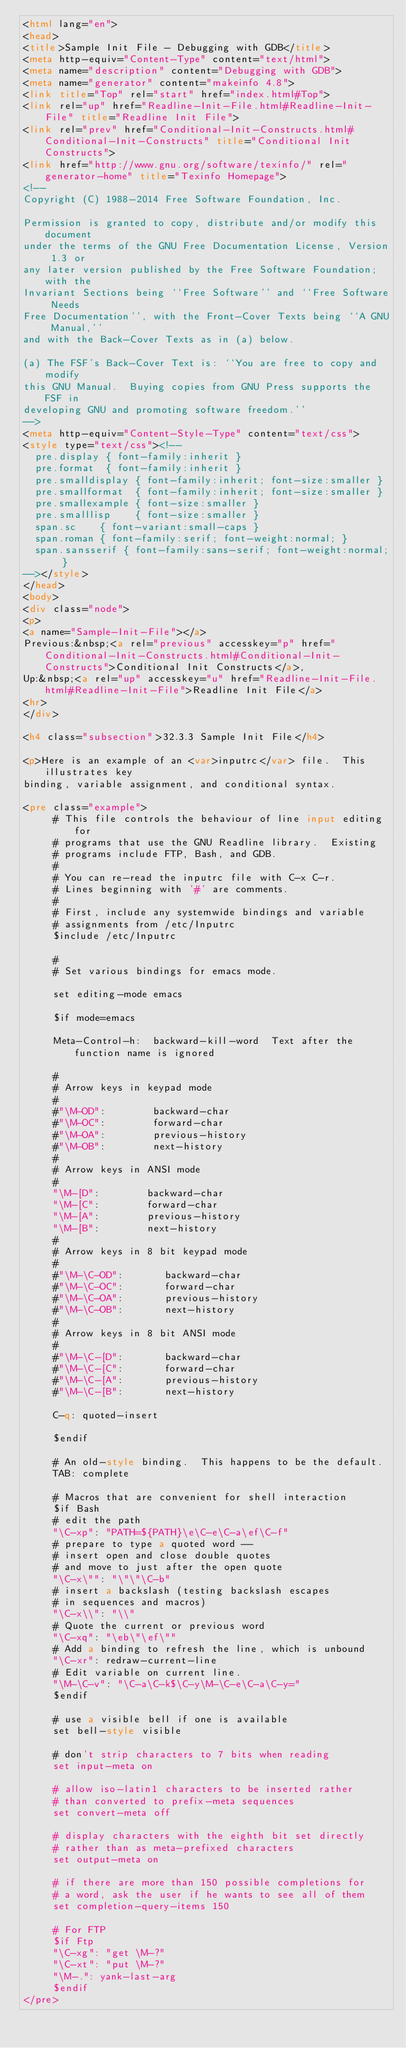<code> <loc_0><loc_0><loc_500><loc_500><_HTML_><html lang="en">
<head>
<title>Sample Init File - Debugging with GDB</title>
<meta http-equiv="Content-Type" content="text/html">
<meta name="description" content="Debugging with GDB">
<meta name="generator" content="makeinfo 4.8">
<link title="Top" rel="start" href="index.html#Top">
<link rel="up" href="Readline-Init-File.html#Readline-Init-File" title="Readline Init File">
<link rel="prev" href="Conditional-Init-Constructs.html#Conditional-Init-Constructs" title="Conditional Init Constructs">
<link href="http://www.gnu.org/software/texinfo/" rel="generator-home" title="Texinfo Homepage">
<!--
Copyright (C) 1988-2014 Free Software Foundation, Inc.

Permission is granted to copy, distribute and/or modify this document
under the terms of the GNU Free Documentation License, Version 1.3 or
any later version published by the Free Software Foundation; with the
Invariant Sections being ``Free Software'' and ``Free Software Needs
Free Documentation'', with the Front-Cover Texts being ``A GNU Manual,''
and with the Back-Cover Texts as in (a) below.

(a) The FSF's Back-Cover Text is: ``You are free to copy and modify
this GNU Manual.  Buying copies from GNU Press supports the FSF in
developing GNU and promoting software freedom.''
-->
<meta http-equiv="Content-Style-Type" content="text/css">
<style type="text/css"><!--
  pre.display { font-family:inherit }
  pre.format  { font-family:inherit }
  pre.smalldisplay { font-family:inherit; font-size:smaller }
  pre.smallformat  { font-family:inherit; font-size:smaller }
  pre.smallexample { font-size:smaller }
  pre.smalllisp    { font-size:smaller }
  span.sc    { font-variant:small-caps }
  span.roman { font-family:serif; font-weight:normal; } 
  span.sansserif { font-family:sans-serif; font-weight:normal; } 
--></style>
</head>
<body>
<div class="node">
<p>
<a name="Sample-Init-File"></a>
Previous:&nbsp;<a rel="previous" accesskey="p" href="Conditional-Init-Constructs.html#Conditional-Init-Constructs">Conditional Init Constructs</a>,
Up:&nbsp;<a rel="up" accesskey="u" href="Readline-Init-File.html#Readline-Init-File">Readline Init File</a>
<hr>
</div>

<h4 class="subsection">32.3.3 Sample Init File</h4>

<p>Here is an example of an <var>inputrc</var> file.  This illustrates key
binding, variable assignment, and conditional syntax.

<pre class="example">     
     # This file controls the behaviour of line input editing for
     # programs that use the GNU Readline library.  Existing
     # programs include FTP, Bash, and GDB.
     #
     # You can re-read the inputrc file with C-x C-r.
     # Lines beginning with '#' are comments.
     #
     # First, include any systemwide bindings and variable
     # assignments from /etc/Inputrc
     $include /etc/Inputrc
     
     #
     # Set various bindings for emacs mode.
     
     set editing-mode emacs
     
     $if mode=emacs
     
     Meta-Control-h:	backward-kill-word	Text after the function name is ignored
     
     #
     # Arrow keys in keypad mode
     #
     #"\M-OD":        backward-char
     #"\M-OC":        forward-char
     #"\M-OA":        previous-history
     #"\M-OB":        next-history
     #
     # Arrow keys in ANSI mode
     #
     "\M-[D":        backward-char
     "\M-[C":        forward-char
     "\M-[A":        previous-history
     "\M-[B":        next-history
     #
     # Arrow keys in 8 bit keypad mode
     #
     #"\M-\C-OD":       backward-char
     #"\M-\C-OC":       forward-char
     #"\M-\C-OA":       previous-history
     #"\M-\C-OB":       next-history
     #
     # Arrow keys in 8 bit ANSI mode
     #
     #"\M-\C-[D":       backward-char
     #"\M-\C-[C":       forward-char
     #"\M-\C-[A":       previous-history
     #"\M-\C-[B":       next-history
     
     C-q: quoted-insert
     
     $endif
     
     # An old-style binding.  This happens to be the default.
     TAB: complete
     
     # Macros that are convenient for shell interaction
     $if Bash
     # edit the path
     "\C-xp": "PATH=${PATH}\e\C-e\C-a\ef\C-f"
     # prepare to type a quoted word --
     # insert open and close double quotes
     # and move to just after the open quote
     "\C-x\"": "\"\"\C-b"
     # insert a backslash (testing backslash escapes
     # in sequences and macros)
     "\C-x\\": "\\"
     # Quote the current or previous word
     "\C-xq": "\eb\"\ef\""
     # Add a binding to refresh the line, which is unbound
     "\C-xr": redraw-current-line
     # Edit variable on current line.
     "\M-\C-v": "\C-a\C-k$\C-y\M-\C-e\C-a\C-y="
     $endif
     
     # use a visible bell if one is available
     set bell-style visible
     
     # don't strip characters to 7 bits when reading
     set input-meta on
     
     # allow iso-latin1 characters to be inserted rather
     # than converted to prefix-meta sequences
     set convert-meta off
     
     # display characters with the eighth bit set directly
     # rather than as meta-prefixed characters
     set output-meta on
     
     # if there are more than 150 possible completions for
     # a word, ask the user if he wants to see all of them
     set completion-query-items 150
     
     # For FTP
     $if Ftp
     "\C-xg": "get \M-?"
     "\C-xt": "put \M-?"
     "\M-.": yank-last-arg
     $endif
</pre></code> 